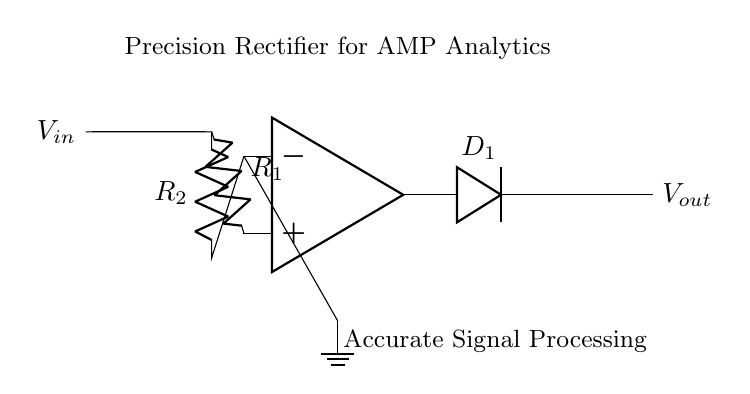What is the function of the diode in this circuit? The diode allows current to flow only in one direction, ensuring that the output voltage reflects the positive portion of the input signal.
Answer: Current direction control What is the role of the operational amplifier? The operational amplifier amplifies the input signal and contributes to the precision rectification process, enabling accurate signal processing.
Answer: Signal amplification What is the resistance value of resistor R1? The circuit does not specify a numerical value for R1, so the resistance value is not directly answerable from the diagram.
Answer: Not specified What type of rectifier is this circuit? This is a precision rectifier, which provides high accuracy in capturing the input signal’s positive components without traditional diode forward voltage drops.
Answer: Precision rectifier How many resistors are present in this circuit? There are two resistors labeled R1 and R2 in the diagram, indicating their presence in the circuit.
Answer: Two What happens to the output voltage when the input voltage is negative? The output voltage will be zero when the input voltage is negative, as the diode will become reverse-biased and block the current flow.
Answer: Zero volts What does the feedback loop between the op-amp and R2 achieve? The feedback loop ensures stable operation of the op-amp, creating a path for the input current, which enhances linearity and accuracy in signal processing.
Answer: Stability and accuracy 